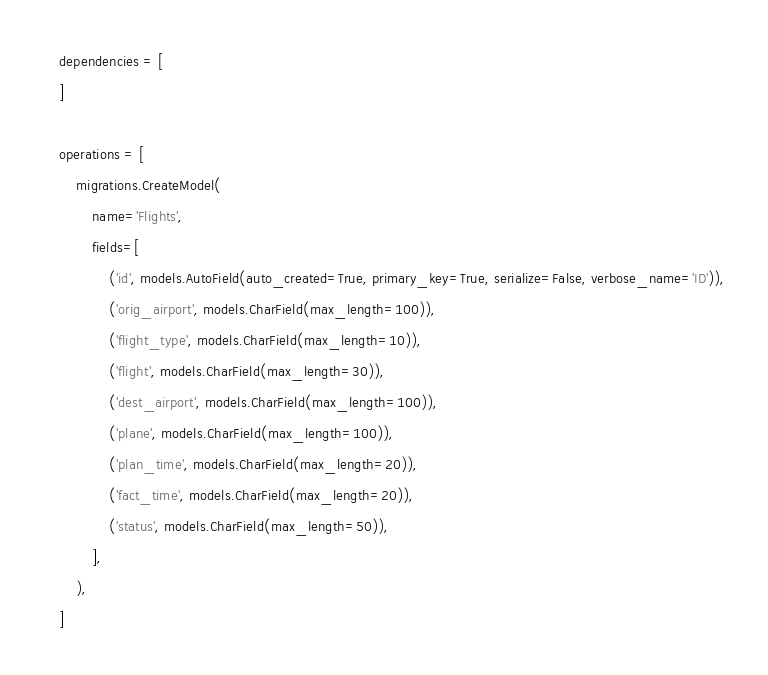<code> <loc_0><loc_0><loc_500><loc_500><_Python_>    dependencies = [
    ]

    operations = [
        migrations.CreateModel(
            name='Flights',
            fields=[
                ('id', models.AutoField(auto_created=True, primary_key=True, serialize=False, verbose_name='ID')),
                ('orig_airport', models.CharField(max_length=100)),
                ('flight_type', models.CharField(max_length=10)),
                ('flight', models.CharField(max_length=30)),
                ('dest_airport', models.CharField(max_length=100)),
                ('plane', models.CharField(max_length=100)),
                ('plan_time', models.CharField(max_length=20)),
                ('fact_time', models.CharField(max_length=20)),
                ('status', models.CharField(max_length=50)),
            ],
        ),
    ]
</code> 